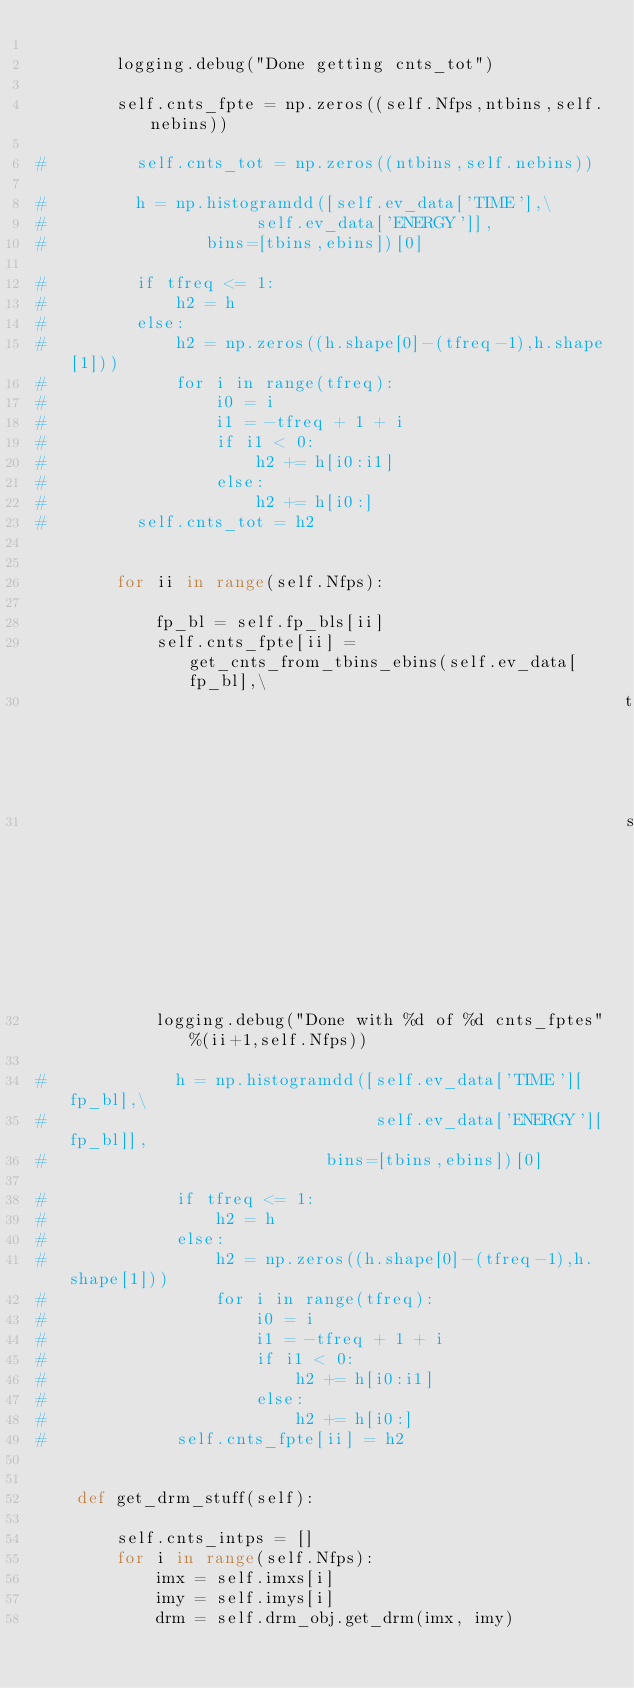Convert code to text. <code><loc_0><loc_0><loc_500><loc_500><_Python_>
        logging.debug("Done getting cnts_tot")

        self.cnts_fpte = np.zeros((self.Nfps,ntbins,self.nebins))

#         self.cnts_tot = np.zeros((ntbins,self.nebins))

#         h = np.histogramdd([self.ev_data['TIME'],\
#                     self.ev_data['ENERGY']],
#                bins=[tbins,ebins])[0]

#         if tfreq <= 1:
#             h2 = h
#         else:
#             h2 = np.zeros((h.shape[0]-(tfreq-1),h.shape[1]))
#             for i in range(tfreq):
#                 i0 = i
#                 i1 = -tfreq + 1 + i
#                 if i1 < 0:
#                     h2 += h[i0:i1]
#                 else:
#                     h2 += h[i0:]
#         self.cnts_tot = h2


        for ii in range(self.Nfps):

            fp_bl = self.fp_bls[ii]
            self.cnts_fpte[ii] = get_cnts_from_tbins_ebins(self.ev_data[fp_bl],\
                                                           tbins0, tbins1,\
                                                           self.ebins0, self.ebins1)
            logging.debug("Done with %d of %d cnts_fptes"%(ii+1,self.Nfps))

#             h = np.histogramdd([self.ev_data['TIME'][fp_bl],\
#                                 self.ev_data['ENERGY'][fp_bl]],
#                            bins=[tbins,ebins])[0]

#             if tfreq <= 1:
#                 h2 = h
#             else:
#                 h2 = np.zeros((h.shape[0]-(tfreq-1),h.shape[1]))
#                 for i in range(tfreq):
#                     i0 = i
#                     i1 = -tfreq + 1 + i
#                     if i1 < 0:
#                         h2 += h[i0:i1]
#                     else:
#                         h2 += h[i0:]
#             self.cnts_fpte[ii] = h2


    def get_drm_stuff(self):

        self.cnts_intps = []
        for i in range(self.Nfps):
            imx = self.imxs[i]
            imy = self.imys[i]
            drm = self.drm_obj.get_drm(imx, imy)</code> 